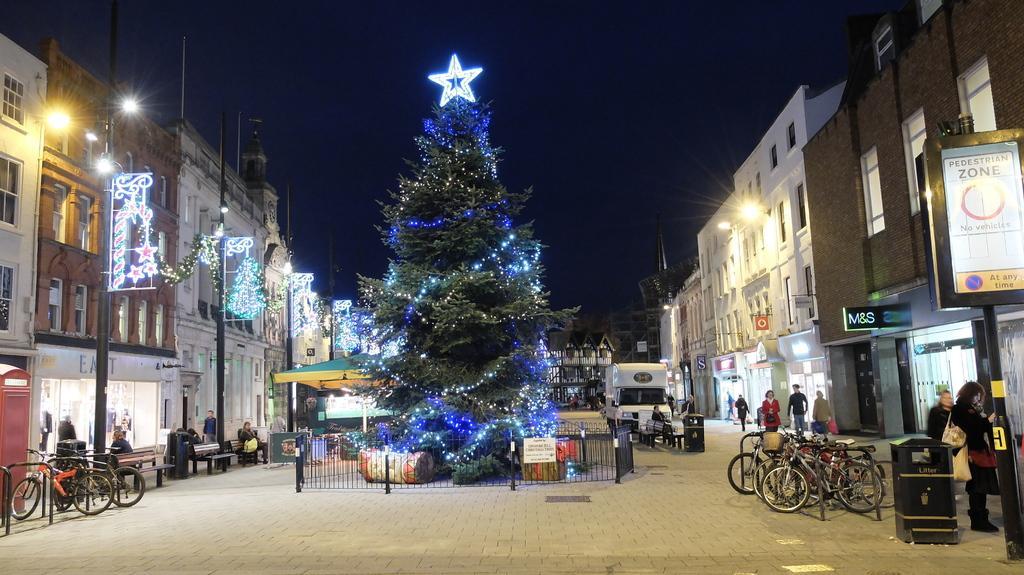In one or two sentences, can you explain what this image depicts? In this picture we can see a few vehicles and some people on the path. There are a few people sitting on the benches. We can see street lights, some text, signs and a few things on the boards. There are buildings and other objects. We can see lights and decorative items on a tree. 